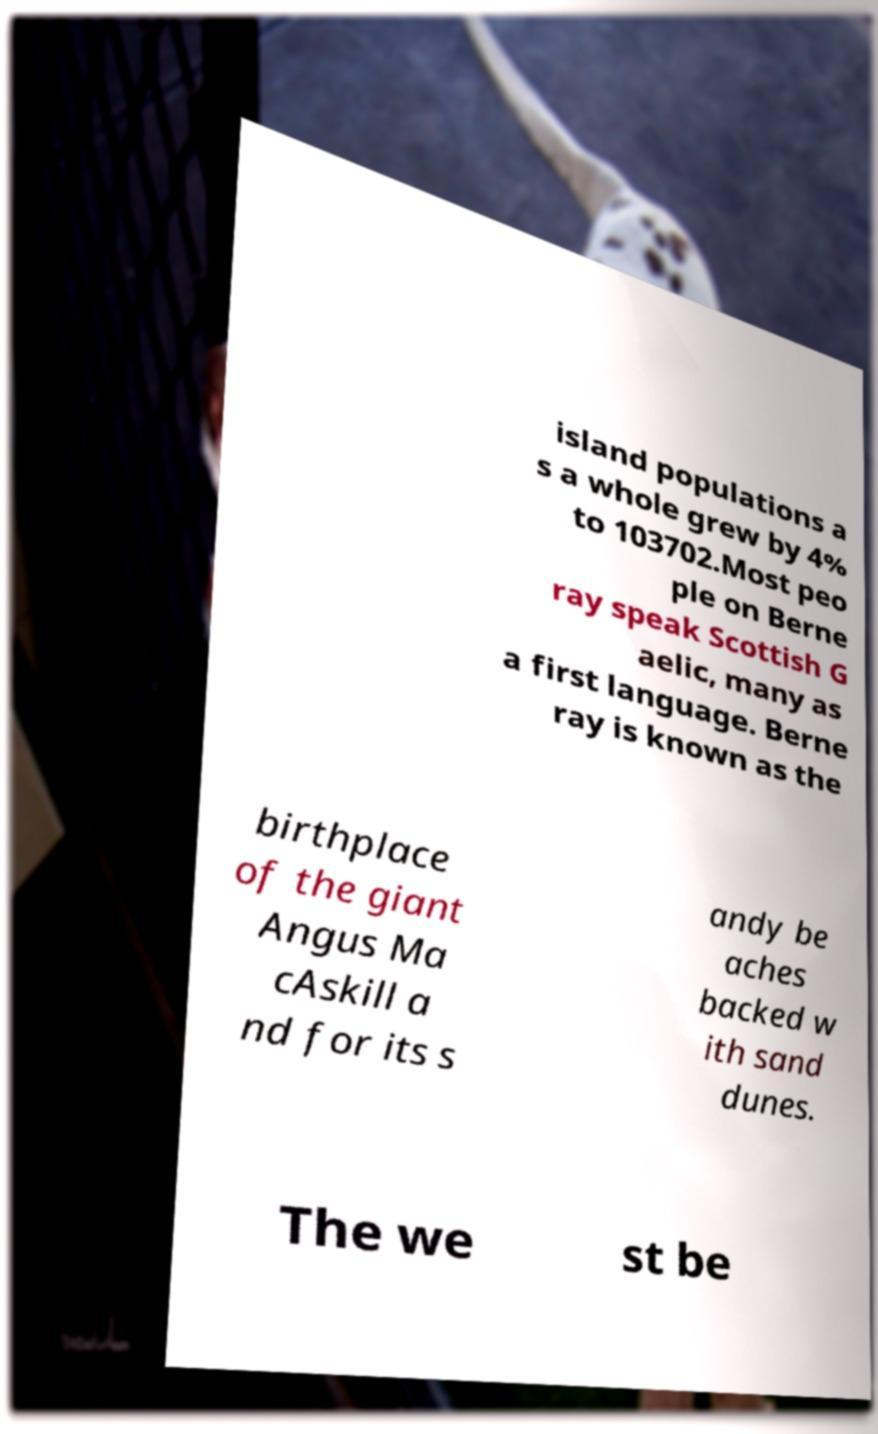Please identify and transcribe the text found in this image. island populations a s a whole grew by 4% to 103702.Most peo ple on Berne ray speak Scottish G aelic, many as a first language. Berne ray is known as the birthplace of the giant Angus Ma cAskill a nd for its s andy be aches backed w ith sand dunes. The we st be 